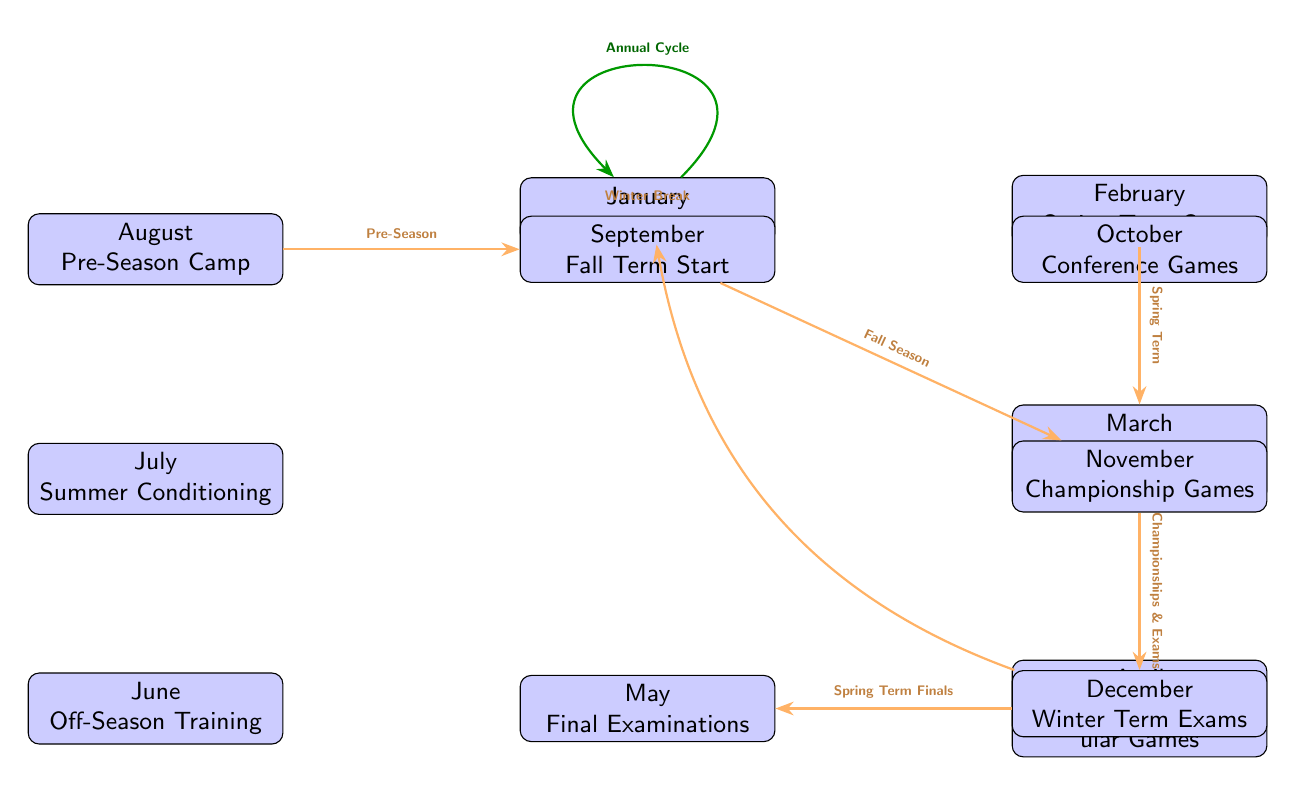What is the first event listed in the diagram? The first event in the diagram is "January" which indicates the "Winter Break" period for student-athletes. This is positioned at the top of the diagram as the starting point.
Answer: January How many events are shown in the diagram? The diagram displays a total of 12 distinct events for each month from January to December. This includes practices, exams, and breaks listed throughout the year.
Answer: 12 Which event immediately follows the "August" node? Following the "August" node, which represents "Pre-Season Camp," the next event listed is "September," marking the "Fall Term Start." This transition shows the chronological flow of events.
Answer: September What connections exist between "November" and "December"? The connection between "November," which indicates "Championship Games," and "December," which lists "Winter Term Exams," is indicated by a directed edge labeled "Championships & Exams." This shows the progression from championship games to exams.
Answer: Championships & Exams What is the last event in the diagram before returning to January? The last event before returning to January is "December," which highlights "Winter Term Exams." The edge labeled "Winter Break" indicates the cyclical nature of the academic calendar.
Answer: December In what month do mid-term examinations occur? Mid-term examinations occur in "March," as indicated in the diagram. This is a focused period for academic assessment during the Spring Term.
Answer: March Which month is associated with off-season training? The month associated with "Off-Season Training" is "June." This is a dedicated period for athletes to train outside of their main competitive season.
Answer: June What is indicated by the green circular arrow in the diagram? The green circular arrow in the diagram signifies the "Annual Cycle," illustrating the repetitive nature of the events in the academic calendar for student-athletes throughout the year.
Answer: Annual Cycle What is the role of the "transition" arrows in the diagram? The "transition" arrows connect various events and indicate the flow of time or progression from one event to the next. Each arrow represents a significant transition within the academic and athletic schedule.
Answer: Flow of time 